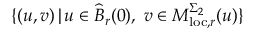Convert formula to latex. <formula><loc_0><loc_0><loc_500><loc_500>\{ ( u , v ) \, | \, u \in \widehat { B } _ { r } ( 0 ) , \, v \in M _ { l o c , r } ^ { \Sigma _ { 2 } } ( u ) \}</formula> 